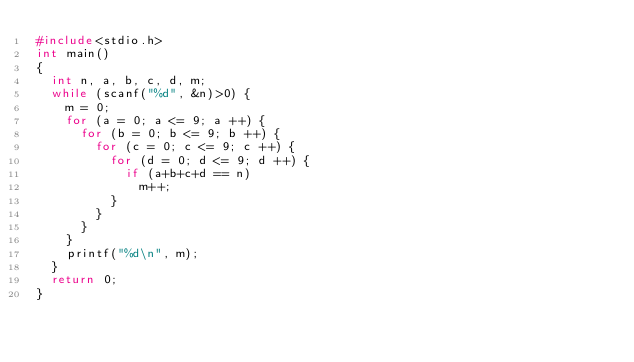<code> <loc_0><loc_0><loc_500><loc_500><_C_>#include<stdio.h>
int main()
{
	int n, a, b, c, d, m;
	while (scanf("%d", &n)>0) {
		m = 0;
		for (a = 0; a <= 9; a ++) {
			for (b = 0; b <= 9; b ++) {
				for (c = 0; c <= 9; c ++) {
					for (d = 0; d <= 9; d ++) {
						if (a+b+c+d == n)
							m++;
					}
				}
			}
		}
		printf("%d\n", m);
	}
	return 0;
}</code> 